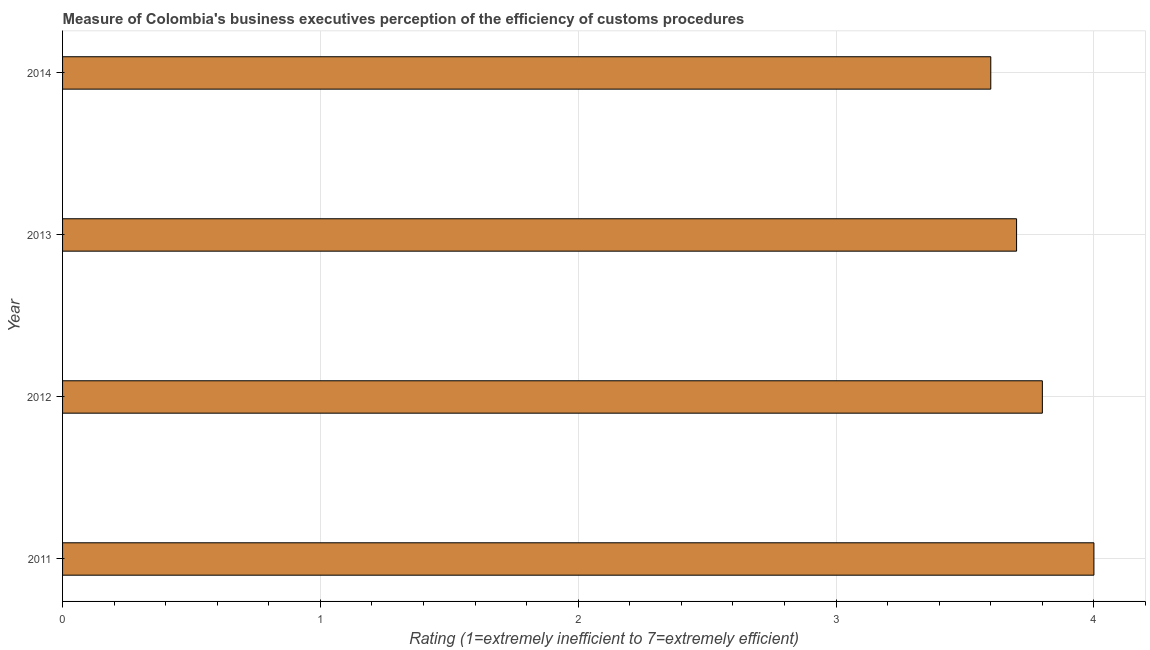Does the graph contain any zero values?
Offer a very short reply. No. Does the graph contain grids?
Your answer should be very brief. Yes. What is the title of the graph?
Give a very brief answer. Measure of Colombia's business executives perception of the efficiency of customs procedures. What is the label or title of the X-axis?
Your answer should be compact. Rating (1=extremely inefficient to 7=extremely efficient). In which year was the rating measuring burden of customs procedure maximum?
Your answer should be very brief. 2011. In which year was the rating measuring burden of customs procedure minimum?
Your answer should be compact. 2014. What is the difference between the rating measuring burden of customs procedure in 2011 and 2013?
Your response must be concise. 0.3. What is the average rating measuring burden of customs procedure per year?
Ensure brevity in your answer.  3.77. What is the median rating measuring burden of customs procedure?
Make the answer very short. 3.75. Do a majority of the years between 2014 and 2011 (inclusive) have rating measuring burden of customs procedure greater than 1 ?
Keep it short and to the point. Yes. What is the ratio of the rating measuring burden of customs procedure in 2011 to that in 2013?
Give a very brief answer. 1.08. Is the sum of the rating measuring burden of customs procedure in 2011 and 2014 greater than the maximum rating measuring burden of customs procedure across all years?
Provide a succinct answer. Yes. What is the difference between the highest and the lowest rating measuring burden of customs procedure?
Your answer should be compact. 0.4. In how many years, is the rating measuring burden of customs procedure greater than the average rating measuring burden of customs procedure taken over all years?
Provide a short and direct response. 2. Are all the bars in the graph horizontal?
Provide a succinct answer. Yes. Are the values on the major ticks of X-axis written in scientific E-notation?
Keep it short and to the point. No. What is the Rating (1=extremely inefficient to 7=extremely efficient) of 2011?
Ensure brevity in your answer.  4. What is the Rating (1=extremely inefficient to 7=extremely efficient) of 2012?
Offer a very short reply. 3.8. What is the Rating (1=extremely inefficient to 7=extremely efficient) in 2013?
Your answer should be very brief. 3.7. What is the Rating (1=extremely inefficient to 7=extremely efficient) of 2014?
Keep it short and to the point. 3.6. What is the difference between the Rating (1=extremely inefficient to 7=extremely efficient) in 2011 and 2012?
Offer a terse response. 0.2. What is the difference between the Rating (1=extremely inefficient to 7=extremely efficient) in 2011 and 2013?
Give a very brief answer. 0.3. What is the difference between the Rating (1=extremely inefficient to 7=extremely efficient) in 2011 and 2014?
Ensure brevity in your answer.  0.4. What is the difference between the Rating (1=extremely inefficient to 7=extremely efficient) in 2012 and 2013?
Your answer should be very brief. 0.1. What is the ratio of the Rating (1=extremely inefficient to 7=extremely efficient) in 2011 to that in 2012?
Ensure brevity in your answer.  1.05. What is the ratio of the Rating (1=extremely inefficient to 7=extremely efficient) in 2011 to that in 2013?
Give a very brief answer. 1.08. What is the ratio of the Rating (1=extremely inefficient to 7=extremely efficient) in 2011 to that in 2014?
Ensure brevity in your answer.  1.11. What is the ratio of the Rating (1=extremely inefficient to 7=extremely efficient) in 2012 to that in 2013?
Your response must be concise. 1.03. What is the ratio of the Rating (1=extremely inefficient to 7=extremely efficient) in 2012 to that in 2014?
Give a very brief answer. 1.06. What is the ratio of the Rating (1=extremely inefficient to 7=extremely efficient) in 2013 to that in 2014?
Provide a short and direct response. 1.03. 